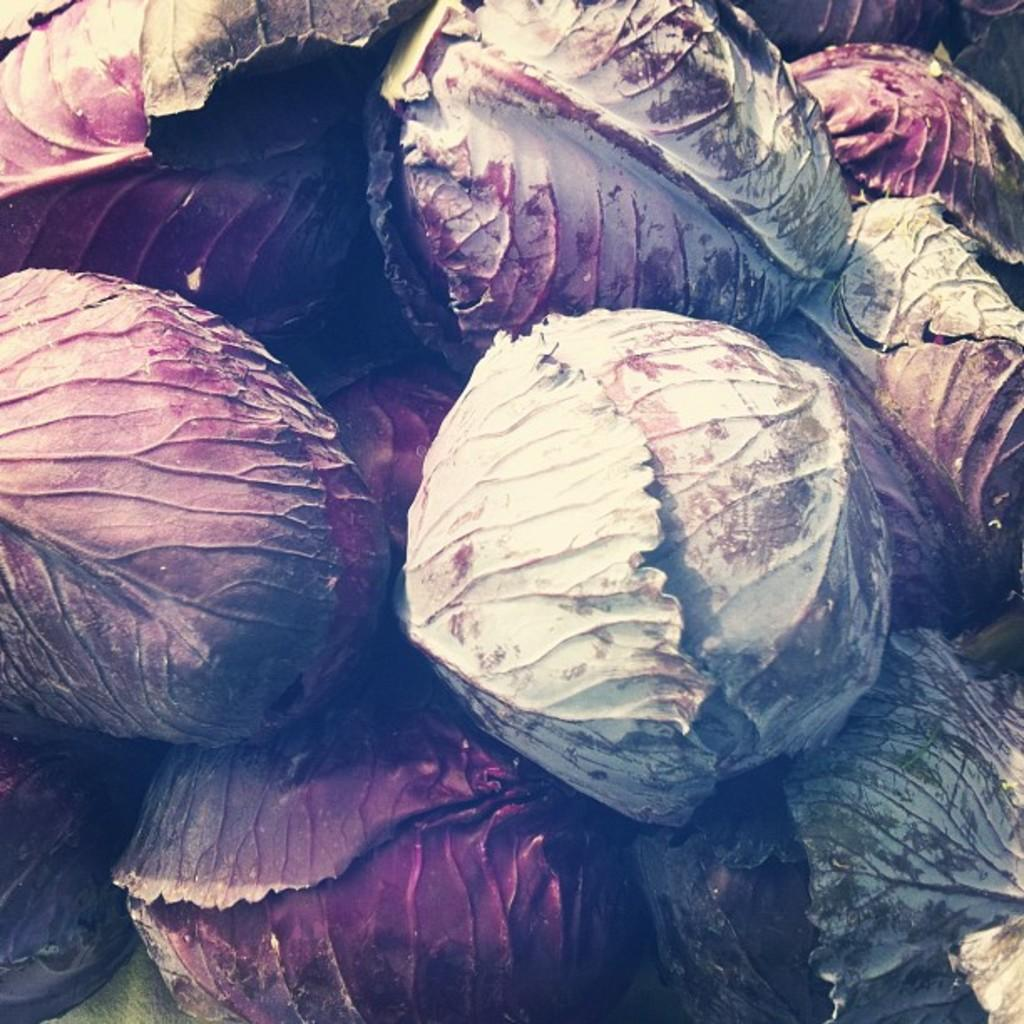What type of vegetables are present in the image? The image contains colorful cabbages. Can you describe the appearance of the cabbages? The cabbages are colorful, which suggests they may have a variety of hues or shades. What type of glove is being used to manipulate the cabbages in the image? There is no glove present in the image, and the cabbages are not being manipulated. 